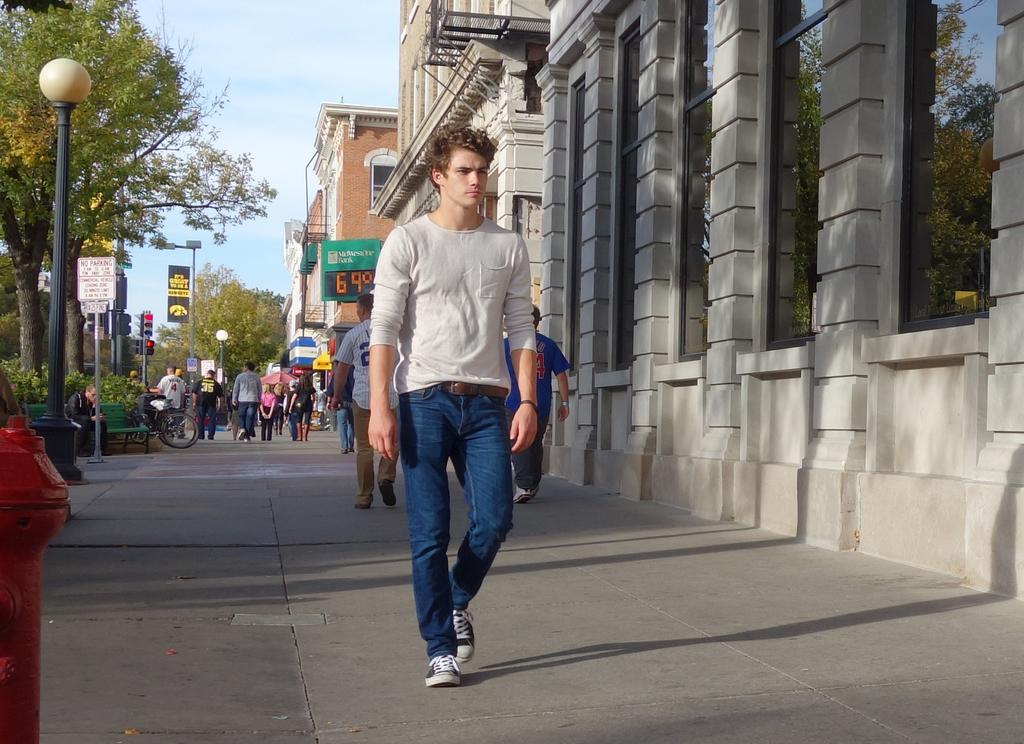Could you give a brief overview of what you see in this image? In this image I can see a path and on it I can see number of people are standing. I can also see few buildings, poles, few boards, trees, lights, signal lights, the sky, shadows and on these boards I can see something is written. Here I can see a red colour fire hydrant. 